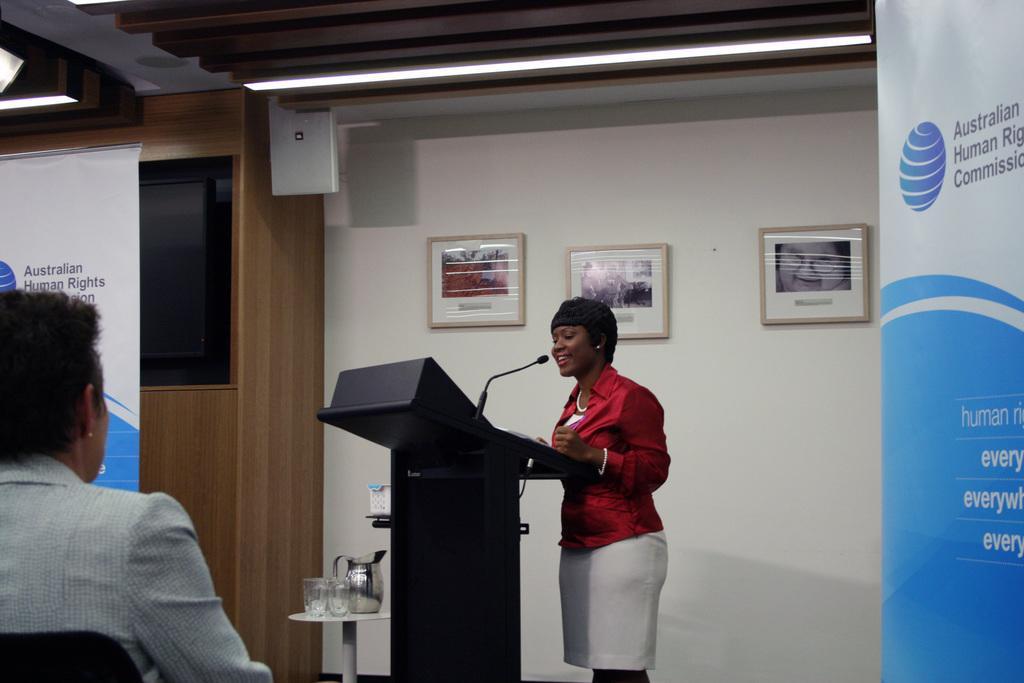How would you summarize this image in a sentence or two? In this image we can see a woman standing beside a speaker stand containing a mic. We can also see a jar and some glasses on a table, a television and some photo frames on a wall, some banners with text on them and a roof with a device and the ceiling lights. On the left side we can see a person sitting on a chair. 